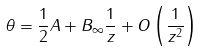<formula> <loc_0><loc_0><loc_500><loc_500>\theta = \frac { 1 } { 2 } A + B _ { \infty } \frac { 1 } { z } + O \left ( \frac { 1 } { z ^ { 2 } } \right )</formula> 